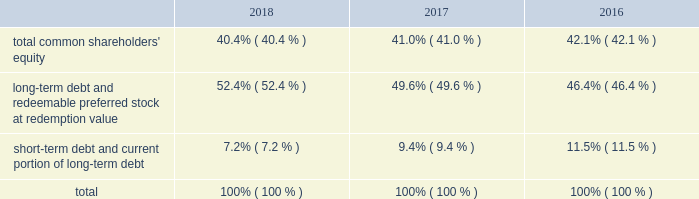Allows us to repurchase shares at times when we may otherwise be prevented from doing so under insider trading laws or because of self-imposed trading blackout periods .
Subject to applicable regulations , we may elect to amend or cancel this repurchase program or the share repurchase parameters at our discretion .
As of december 31 , 2018 , we have repurchased an aggregate of 4510000 shares of common stock under this program .
Credit facilities and short-term debt we have an unsecured revolving credit facility of $ 2.25 billion that expires in june 2023 .
In march 2018 , awcc and its lenders amended and restated the credit agreement with respect to awcc 2019s revolving credit facility to increase the maximum commitments under the facility from $ 1.75 billion to $ 2.25 billion , and to extend the expiration date of the facility from june 2020 to march 2023 .
All other terms , conditions and covenants with respect to the existing facility remained unchanged .
Subject to satisfying certain conditions , the credit agreement also permits awcc to increase the maximum commitment under the facility by up to an aggregate of $ 500 million , and to request extensions of its expiration date for up to two , one-year periods .
Interest rates on advances under the facility are based on a credit spread to the libor rate or base rate in accordance with moody investors service 2019s and standard & poor 2019s financial services 2019 then applicable credit rating on awcc 2019s senior unsecured , non-credit enhanced debt .
The facility is used principally to support awcc 2019s commercial paper program and to provide up to $ 150 million in letters of credit .
Indebtedness under the facility is considered 201cdebt 201d for purposes of a support agreement between the company and awcc , which serves as a functional equivalent of a guarantee by the company of awcc 2019s payment obligations under the credit facility .
Awcc also has an outstanding commercial paper program that is backed by the revolving credit facility , the maximum aggregate outstanding amount of which was increased in march 2018 , from $ 1.60 billion to $ 2.10 billion .
The table provides the aggregate credit facility commitments , letter of credit sub-limit under the revolving credit facility and commercial paper limit , as well as the available capacity for each as of december 31 , 2018 and 2017 : credit facility commitment available credit facility capacity letter of credit sublimit available letter of credit capacity commercial paper limit available commercial capacity ( in millions ) december 31 , 2018 .
$ 2262 $ 2177 $ 150 $ 69 $ 2100 $ 1146 december 31 , 2017 .
1762 1673 150 66 1600 695 the weighted average interest rate on awcc short-term borrowings for the years ended december 31 , 2018 and 2017 was approximately 2.28% ( 2.28 % ) and 1.24% ( 1.24 % ) , respectively .
Capital structure the table provides the percentage of our capitalization represented by the components of our capital structure as of december 31: .

Was the weighted average interest rate on awcc short-term borrowings greater for the year ended december 31 , 2018 then 2017? 
Computations: (2.28 > 1.24)
Answer: yes. 